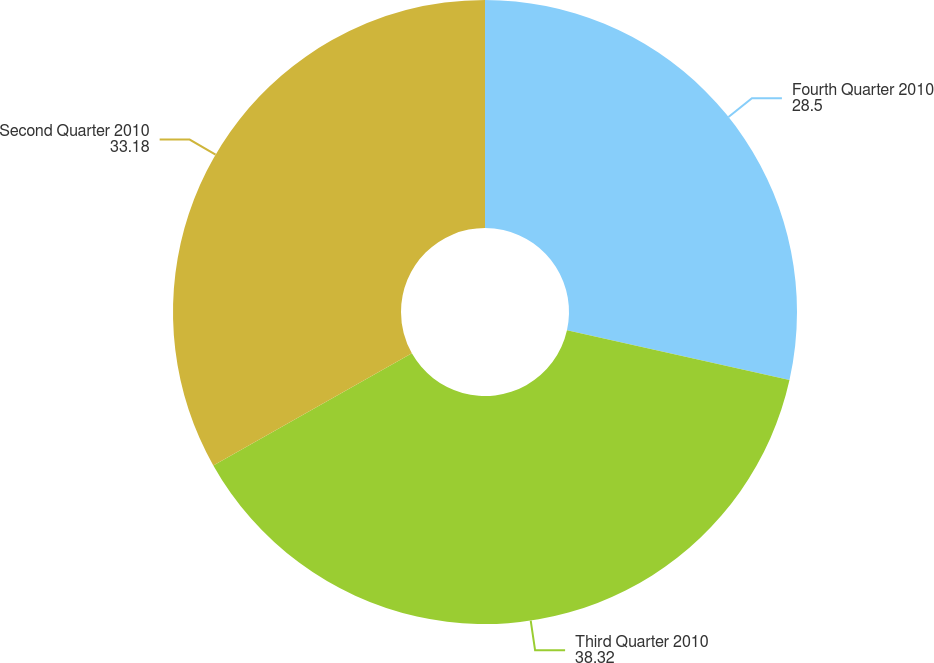Convert chart to OTSL. <chart><loc_0><loc_0><loc_500><loc_500><pie_chart><fcel>Fourth Quarter 2010<fcel>Third Quarter 2010<fcel>Second Quarter 2010<nl><fcel>28.5%<fcel>38.32%<fcel>33.18%<nl></chart> 